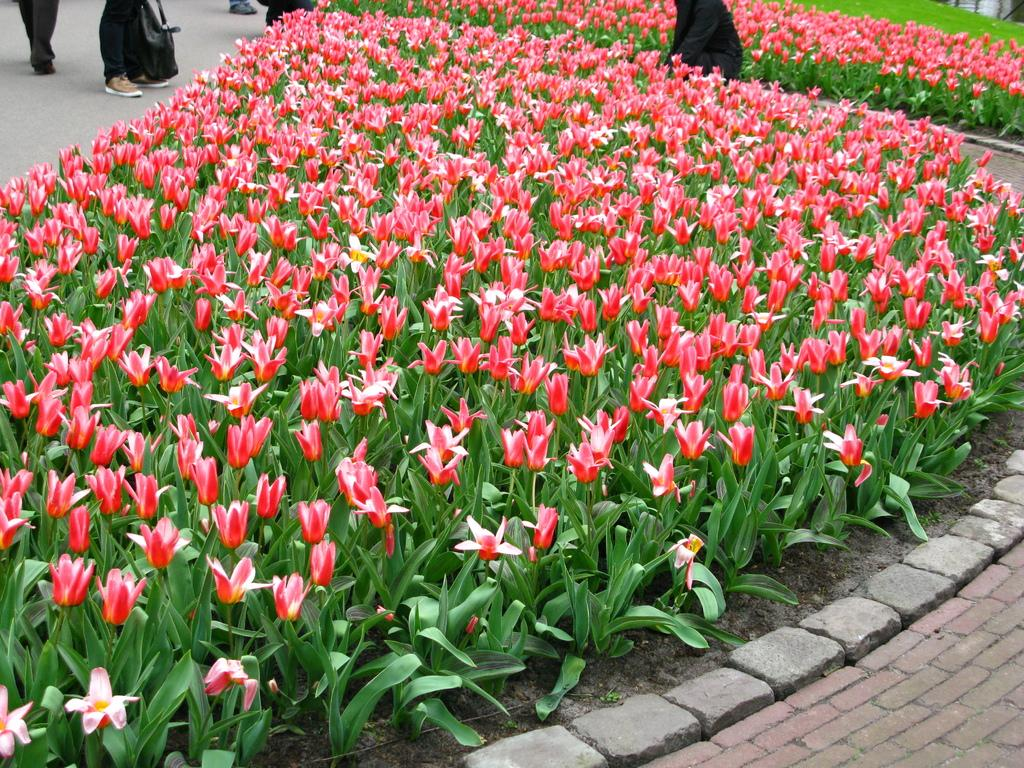What type of flowers can be seen in the image? There are pink tulip flowers in the image. Where are the flowers located? The flowers are on plants. What other elements can be seen in the image? There are stones visible in the image. What is happening in the background of the image? In the background, people are walking on the ground. What type of linen is being used to hold the flowers in the image? There is no linen present in the image; the flowers are on plants. Can you see a fork being used to pick up the stones in the image? There is no fork present in the image, and the stones are not being picked up. 